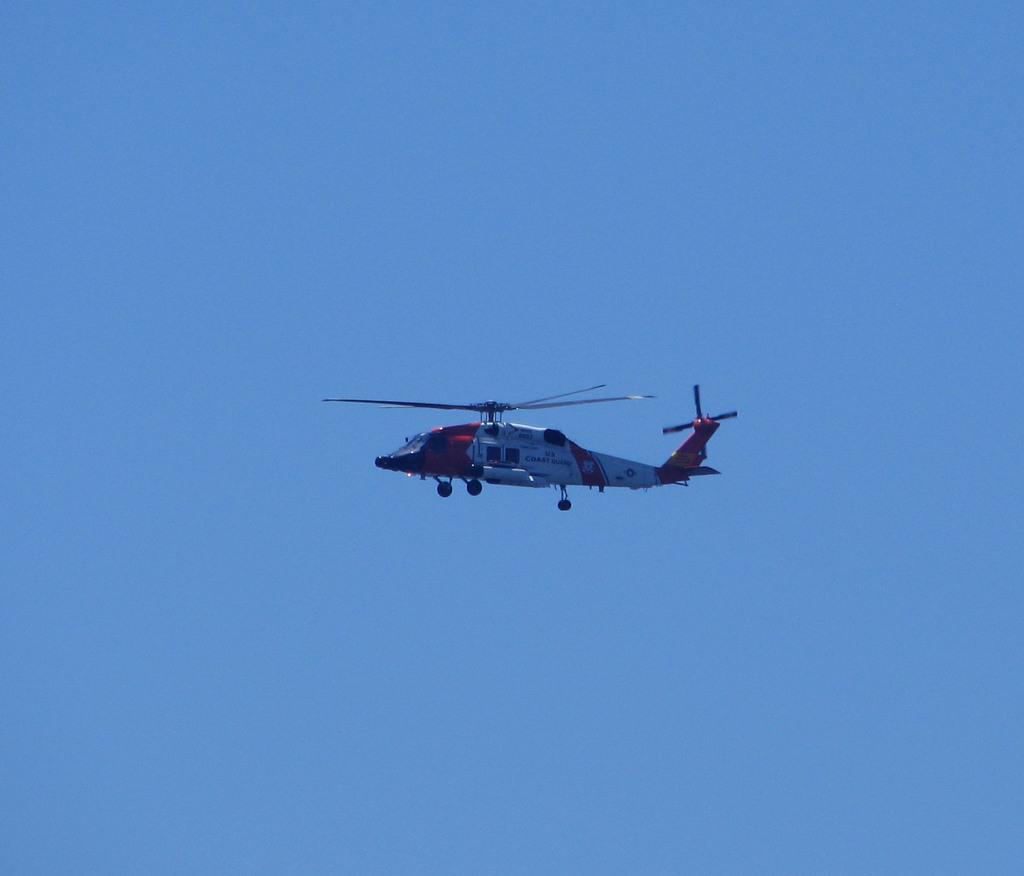What is the main subject of the image? The main subject of the image is a helicopter. What is the helicopter doing in the image? The helicopter is flying in the sky. What type of meal is being served on the helicopter's fork in the image? There is no meal or fork present in the image; it only features a helicopter flying in the sky. 